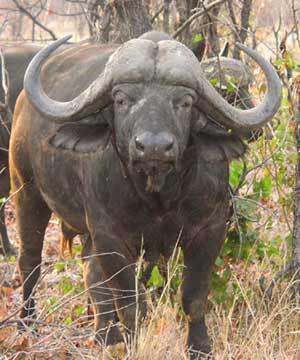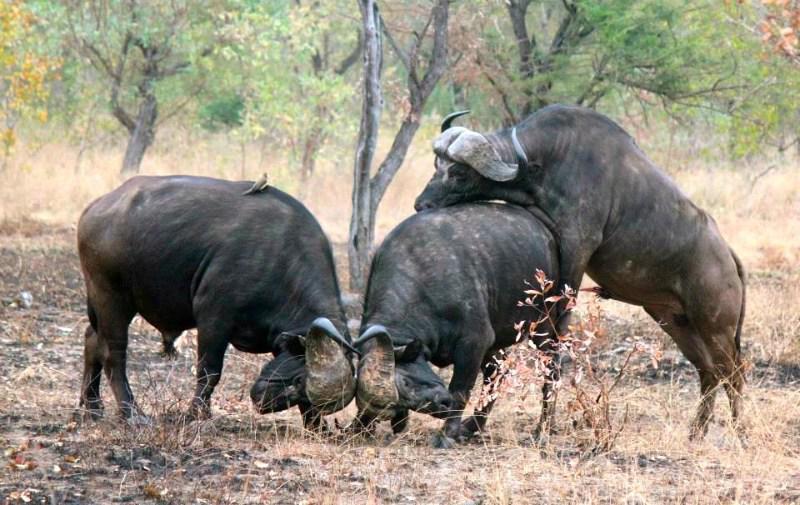The first image is the image on the left, the second image is the image on the right. For the images displayed, is the sentence "There are at most 5 water buffalo." factually correct? Answer yes or no. Yes. The first image is the image on the left, the second image is the image on the right. Given the left and right images, does the statement "There are fewer than 5 water buffalos" hold true? Answer yes or no. Yes. 